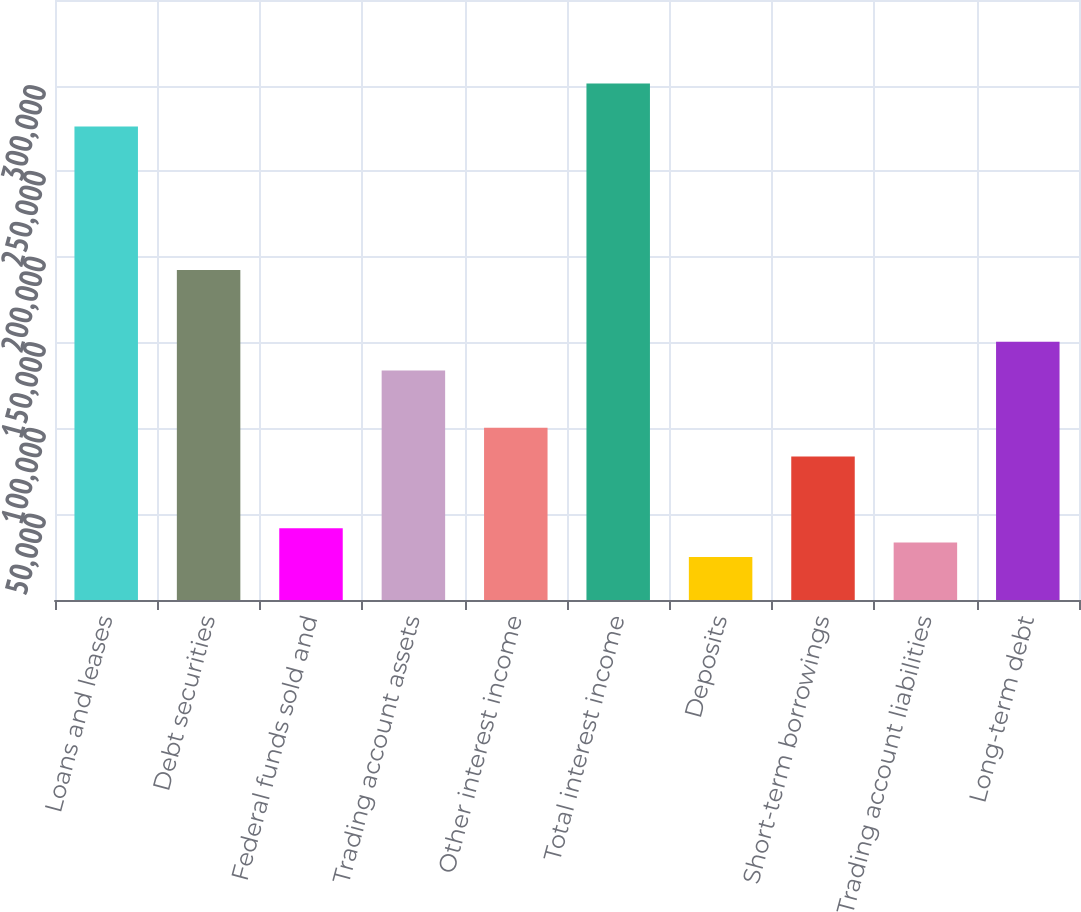<chart> <loc_0><loc_0><loc_500><loc_500><bar_chart><fcel>Loans and leases<fcel>Debt securities<fcel>Federal funds sold and<fcel>Trading account assets<fcel>Other interest income<fcel>Total interest income<fcel>Deposits<fcel>Short-term borrowings<fcel>Trading account liabilities<fcel>Long-term debt<nl><fcel>276210<fcel>192510<fcel>41851.2<fcel>133921<fcel>100441<fcel>301320<fcel>25111.3<fcel>83701<fcel>33481.3<fcel>150661<nl></chart> 